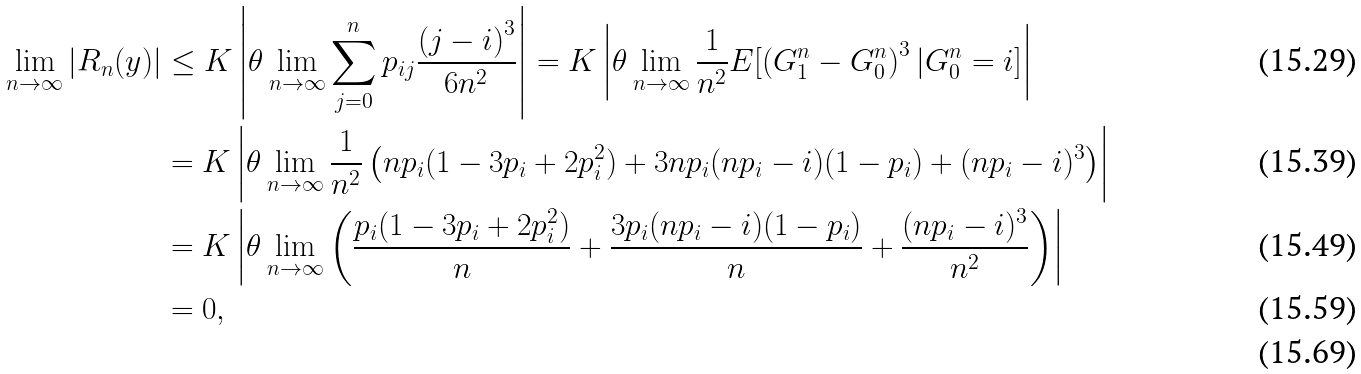<formula> <loc_0><loc_0><loc_500><loc_500>\lim _ { n \to \infty } | R _ { n } ( y ) | & \leq K \left | \theta \lim _ { n \to \infty } \sum _ { j = 0 } ^ { n } p _ { i j } \frac { \left ( j - i \right ) ^ { 3 } } { 6 n ^ { 2 } } \right | = K \left | \theta \lim _ { n \to \infty } \frac { 1 } { n ^ { 2 } } E [ \left ( G ^ { n } _ { 1 } - G ^ { n } _ { 0 } \right ) ^ { 3 } | G ^ { n } _ { 0 } = i ] \right | \\ & = K \left | \theta \lim _ { n \to \infty } \frac { 1 } { n ^ { 2 } } \left ( n p _ { i } ( 1 - 3 p _ { i } + 2 p ^ { 2 } _ { i } ) + 3 n p _ { i } ( n p _ { i } - i ) ( 1 - p _ { i } ) + ( n p _ { i } - i ) ^ { 3 } \right ) \right | \\ & = K \left | \theta \lim _ { n \to \infty } \left ( \frac { p _ { i } ( 1 - 3 p _ { i } + 2 p ^ { 2 } _ { i } ) } { n } + \frac { 3 p _ { i } ( n p _ { i } - i ) ( 1 - p _ { i } ) } { n } + \frac { ( n p _ { i } - i ) ^ { 3 } } { n ^ { 2 } } \right ) \right | \\ & = 0 , \\</formula> 